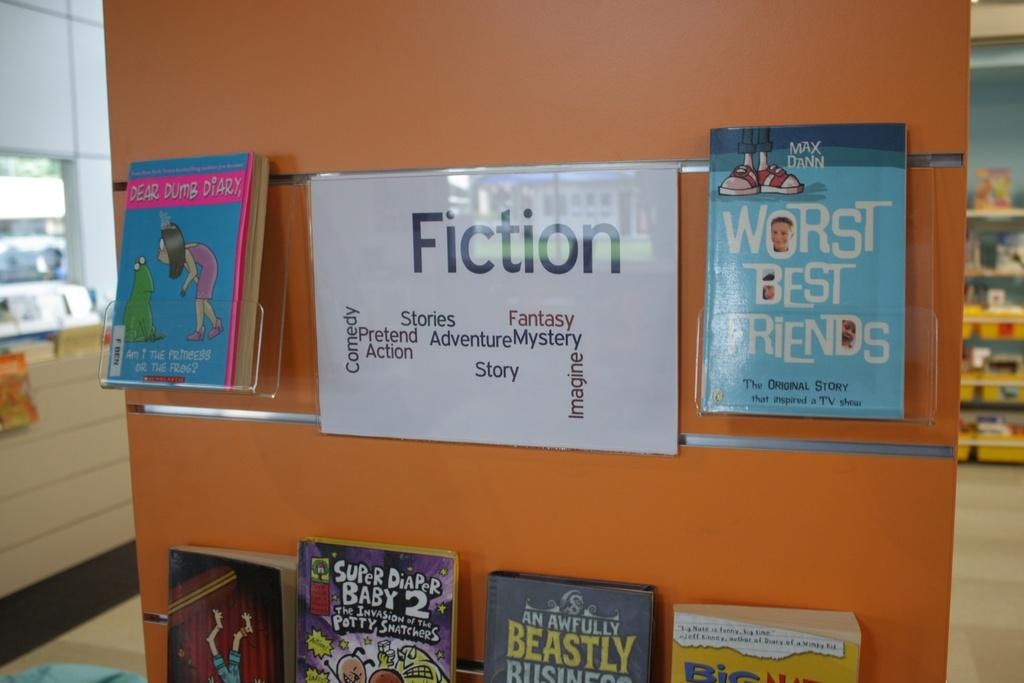Provide a one-sentence caption for the provided image. A wall displaying children's books with the label of Fiction. 